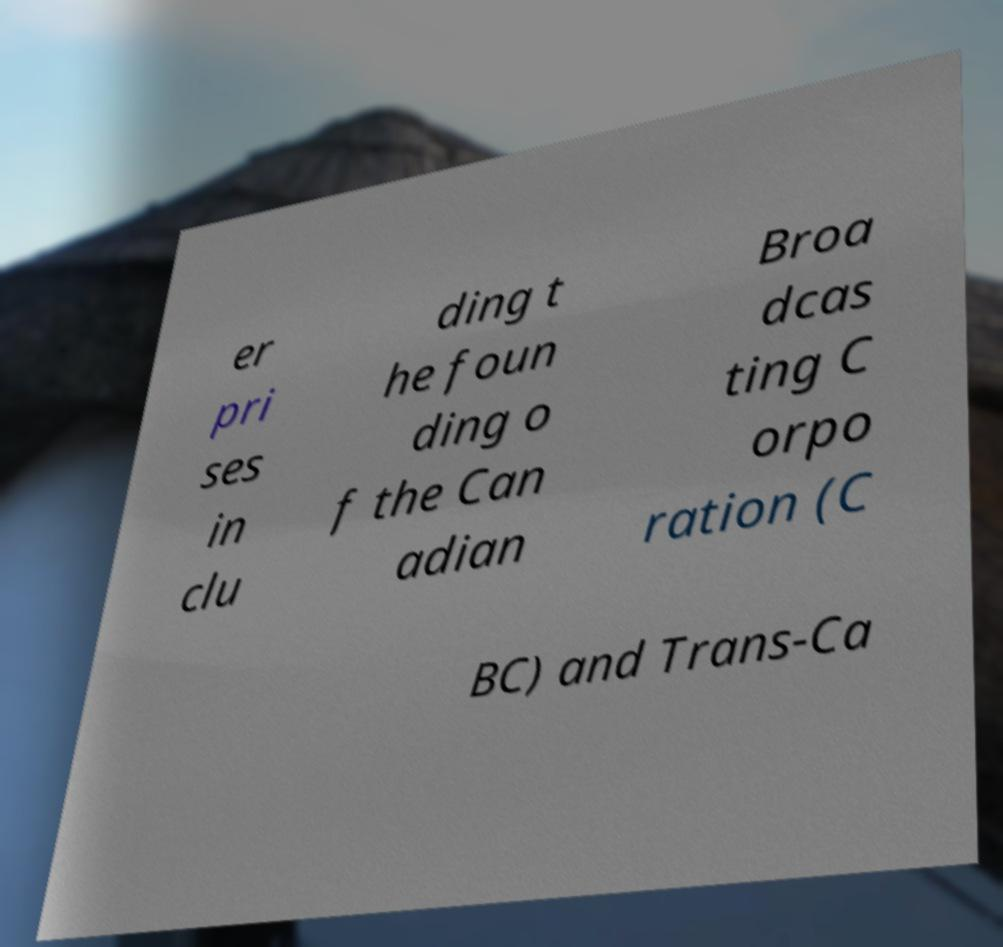Please identify and transcribe the text found in this image. er pri ses in clu ding t he foun ding o f the Can adian Broa dcas ting C orpo ration (C BC) and Trans-Ca 